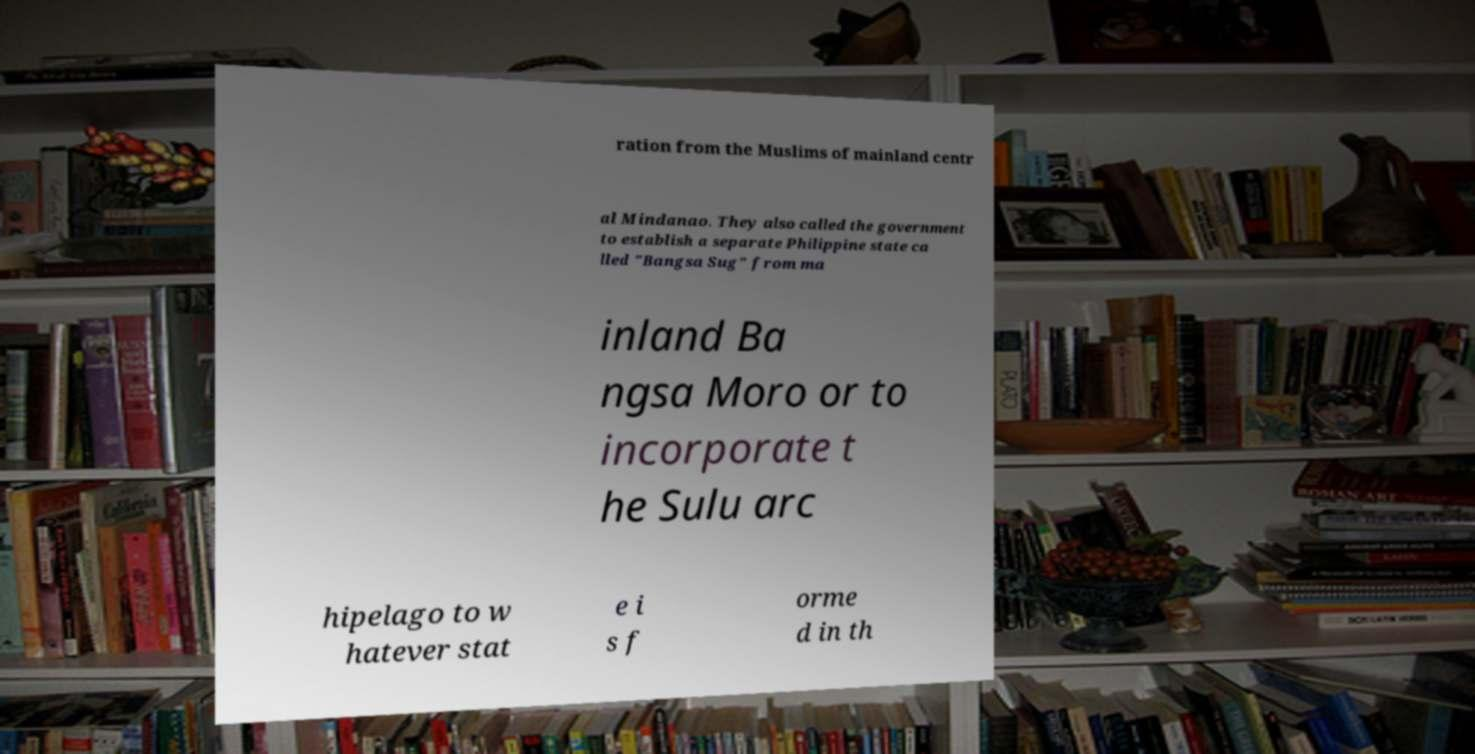There's text embedded in this image that I need extracted. Can you transcribe it verbatim? ration from the Muslims of mainland centr al Mindanao. They also called the government to establish a separate Philippine state ca lled "Bangsa Sug" from ma inland Ba ngsa Moro or to incorporate t he Sulu arc hipelago to w hatever stat e i s f orme d in th 